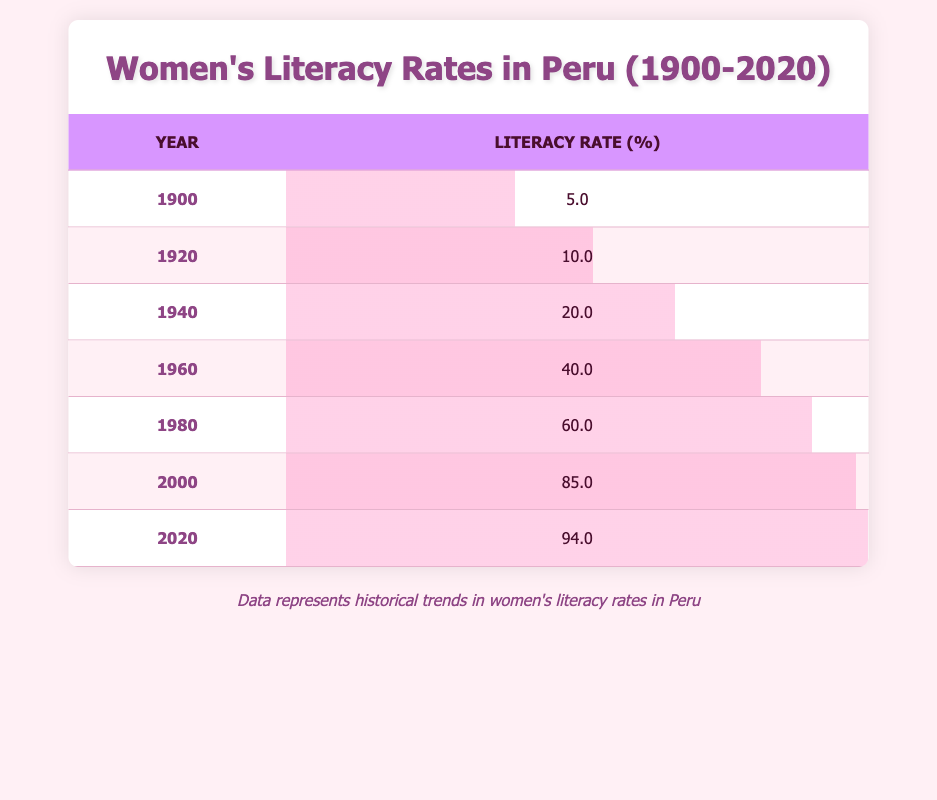What was the women's literacy rate in Peru in 1900? Looking at the table for the year 1900, the literacy rate is listed as 5.0%.
Answer: 5.0% What was the increase in women's literacy rate from 1960 to 2000? For 1960, the literacy rate is 40.0% and for 2000, it is 85.0%. The increase is 85.0% - 40.0% = 45.0%.
Answer: 45.0% Did women's literacy rates in Peru exceed 60% by 1980? In the table, the literacy rate for 1980 is 60.0%. Since 60% is not greater than 60%, the answer is no.
Answer: No What was the average women's literacy rate from 1900 to 2020? The literacy rates over the years are 5.0%, 10.0%, 20.0%, 40.0%, 60.0%, 85.0%, and 94.0%. The sum is 5.0 + 10.0 + 20.0 + 40.0 + 60.0 + 85.0 + 94.0 = 314.0%. There are 7 data points, so the average is 314.0% / 7 = 44.86%.
Answer: 44.86% Which year showed the most significant increase in literacy rates compared to the previous decade? By examining the increases: 1900 to 1920 (+5.0), 1920 to 1940 (+10.0), 1940 to 1960 (+20.0), 1960 to 1980 (+20.0), 1980 to 2000 (+25.0), and 2000 to 2020 (+9.0). The greatest increase was from 1980 to 2000, with a rise of 25.0%.
Answer: 1980 to 2000 What percentage of women were literate in Peru by 2020? The literacy rate in 2020 listed in the table is 94.0%.
Answer: 94.0% Was the literacy rate in 1940 higher than 15%? The literacy rate in 1940 is 20.0%, which is indeed higher than 15%, so the answer is yes.
Answer: Yes Which decade had the lowest literacy rate among the listed years? Comparing all the literacy rates from each of the listed years, 1900 has the lowest rate at 5.0%, which was during the first decade of the 20th century.
Answer: 1900 